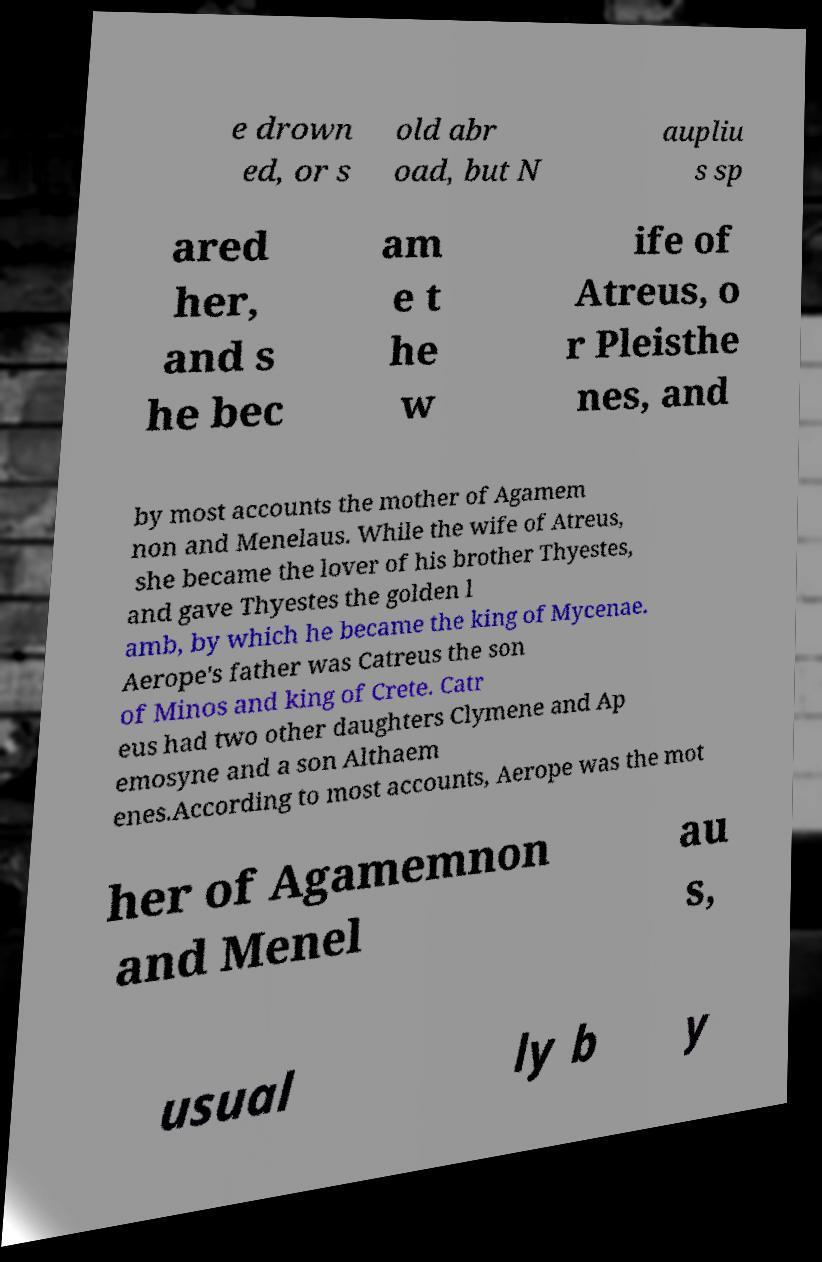Please identify and transcribe the text found in this image. e drown ed, or s old abr oad, but N aupliu s sp ared her, and s he bec am e t he w ife of Atreus, o r Pleisthe nes, and by most accounts the mother of Agamem non and Menelaus. While the wife of Atreus, she became the lover of his brother Thyestes, and gave Thyestes the golden l amb, by which he became the king of Mycenae. Aerope's father was Catreus the son of Minos and king of Crete. Catr eus had two other daughters Clymene and Ap emosyne and a son Althaem enes.According to most accounts, Aerope was the mot her of Agamemnon and Menel au s, usual ly b y 